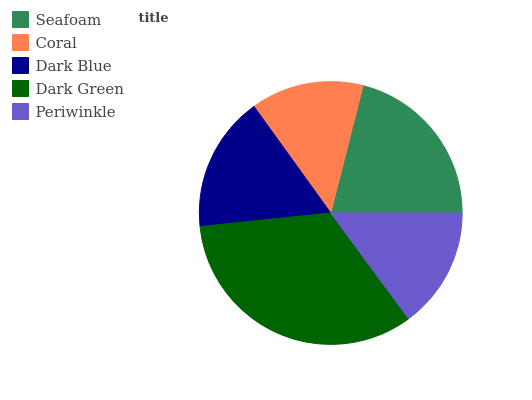Is Coral the minimum?
Answer yes or no. Yes. Is Dark Green the maximum?
Answer yes or no. Yes. Is Dark Blue the minimum?
Answer yes or no. No. Is Dark Blue the maximum?
Answer yes or no. No. Is Dark Blue greater than Coral?
Answer yes or no. Yes. Is Coral less than Dark Blue?
Answer yes or no. Yes. Is Coral greater than Dark Blue?
Answer yes or no. No. Is Dark Blue less than Coral?
Answer yes or no. No. Is Dark Blue the high median?
Answer yes or no. Yes. Is Dark Blue the low median?
Answer yes or no. Yes. Is Periwinkle the high median?
Answer yes or no. No. Is Coral the low median?
Answer yes or no. No. 